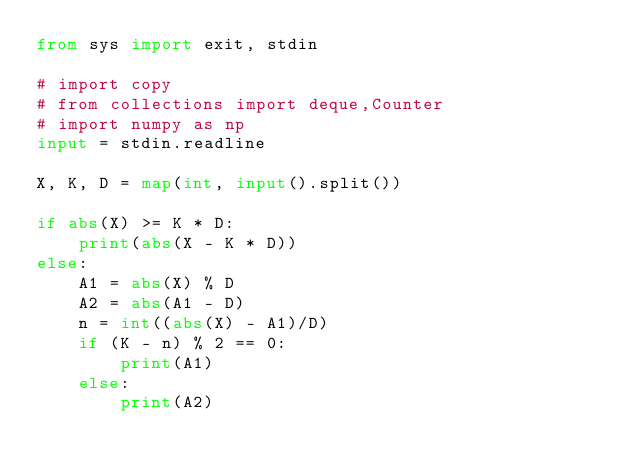<code> <loc_0><loc_0><loc_500><loc_500><_Python_>from sys import exit, stdin

# import copy
# from collections import deque,Counter
# import numpy as np
input = stdin.readline

X, K, D = map(int, input().split())

if abs(X) >= K * D:
    print(abs(X - K * D))
else:
    A1 = abs(X) % D
    A2 = abs(A1 - D)
    n = int((abs(X) - A1)/D)
    if (K - n) % 2 == 0:
        print(A1)
    else:
        print(A2)

</code> 